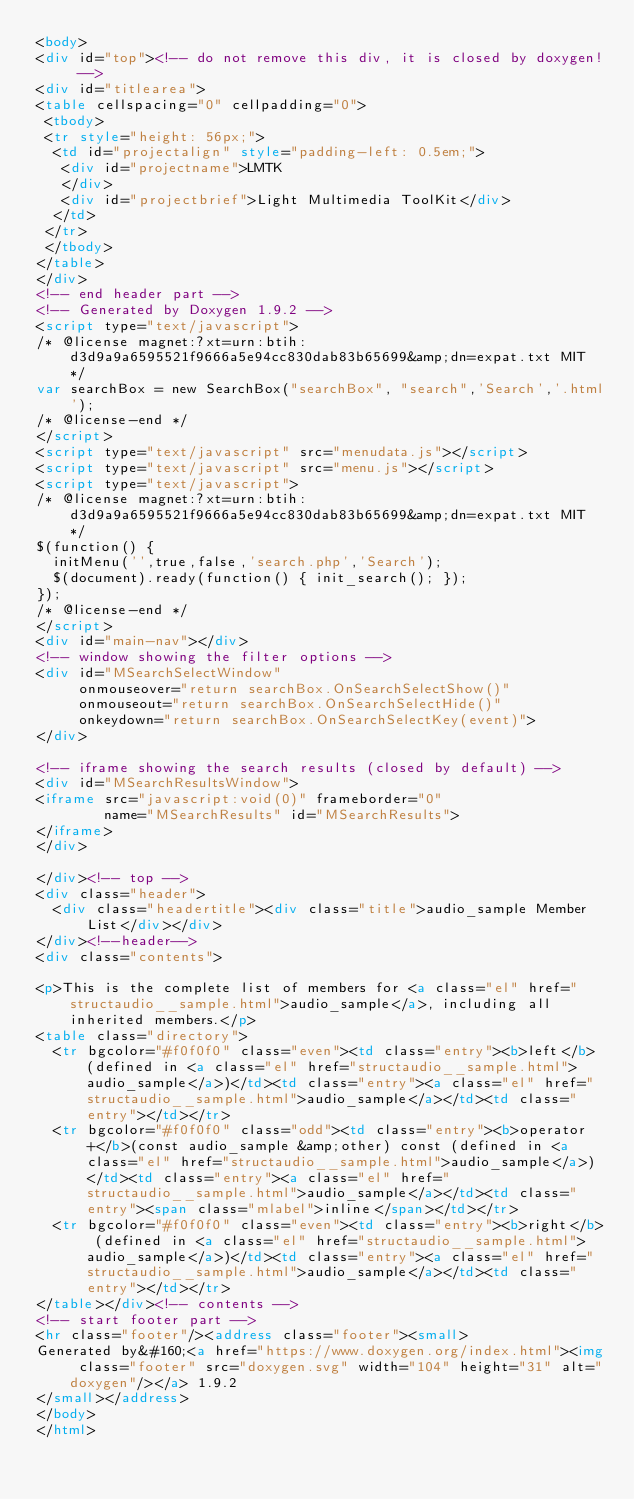Convert code to text. <code><loc_0><loc_0><loc_500><loc_500><_HTML_><body>
<div id="top"><!-- do not remove this div, it is closed by doxygen! -->
<div id="titlearea">
<table cellspacing="0" cellpadding="0">
 <tbody>
 <tr style="height: 56px;">
  <td id="projectalign" style="padding-left: 0.5em;">
   <div id="projectname">LMTK
   </div>
   <div id="projectbrief">Light Multimedia ToolKit</div>
  </td>
 </tr>
 </tbody>
</table>
</div>
<!-- end header part -->
<!-- Generated by Doxygen 1.9.2 -->
<script type="text/javascript">
/* @license magnet:?xt=urn:btih:d3d9a9a6595521f9666a5e94cc830dab83b65699&amp;dn=expat.txt MIT */
var searchBox = new SearchBox("searchBox", "search",'Search','.html');
/* @license-end */
</script>
<script type="text/javascript" src="menudata.js"></script>
<script type="text/javascript" src="menu.js"></script>
<script type="text/javascript">
/* @license magnet:?xt=urn:btih:d3d9a9a6595521f9666a5e94cc830dab83b65699&amp;dn=expat.txt MIT */
$(function() {
  initMenu('',true,false,'search.php','Search');
  $(document).ready(function() { init_search(); });
});
/* @license-end */
</script>
<div id="main-nav"></div>
<!-- window showing the filter options -->
<div id="MSearchSelectWindow"
     onmouseover="return searchBox.OnSearchSelectShow()"
     onmouseout="return searchBox.OnSearchSelectHide()"
     onkeydown="return searchBox.OnSearchSelectKey(event)">
</div>

<!-- iframe showing the search results (closed by default) -->
<div id="MSearchResultsWindow">
<iframe src="javascript:void(0)" frameborder="0" 
        name="MSearchResults" id="MSearchResults">
</iframe>
</div>

</div><!-- top -->
<div class="header">
  <div class="headertitle"><div class="title">audio_sample Member List</div></div>
</div><!--header-->
<div class="contents">

<p>This is the complete list of members for <a class="el" href="structaudio__sample.html">audio_sample</a>, including all inherited members.</p>
<table class="directory">
  <tr bgcolor="#f0f0f0" class="even"><td class="entry"><b>left</b> (defined in <a class="el" href="structaudio__sample.html">audio_sample</a>)</td><td class="entry"><a class="el" href="structaudio__sample.html">audio_sample</a></td><td class="entry"></td></tr>
  <tr bgcolor="#f0f0f0" class="odd"><td class="entry"><b>operator+</b>(const audio_sample &amp;other) const (defined in <a class="el" href="structaudio__sample.html">audio_sample</a>)</td><td class="entry"><a class="el" href="structaudio__sample.html">audio_sample</a></td><td class="entry"><span class="mlabel">inline</span></td></tr>
  <tr bgcolor="#f0f0f0" class="even"><td class="entry"><b>right</b> (defined in <a class="el" href="structaudio__sample.html">audio_sample</a>)</td><td class="entry"><a class="el" href="structaudio__sample.html">audio_sample</a></td><td class="entry"></td></tr>
</table></div><!-- contents -->
<!-- start footer part -->
<hr class="footer"/><address class="footer"><small>
Generated by&#160;<a href="https://www.doxygen.org/index.html"><img class="footer" src="doxygen.svg" width="104" height="31" alt="doxygen"/></a> 1.9.2
</small></address>
</body>
</html>
</code> 